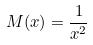Convert formula to latex. <formula><loc_0><loc_0><loc_500><loc_500>M ( x ) = \frac { 1 } { x ^ { 2 } }</formula> 